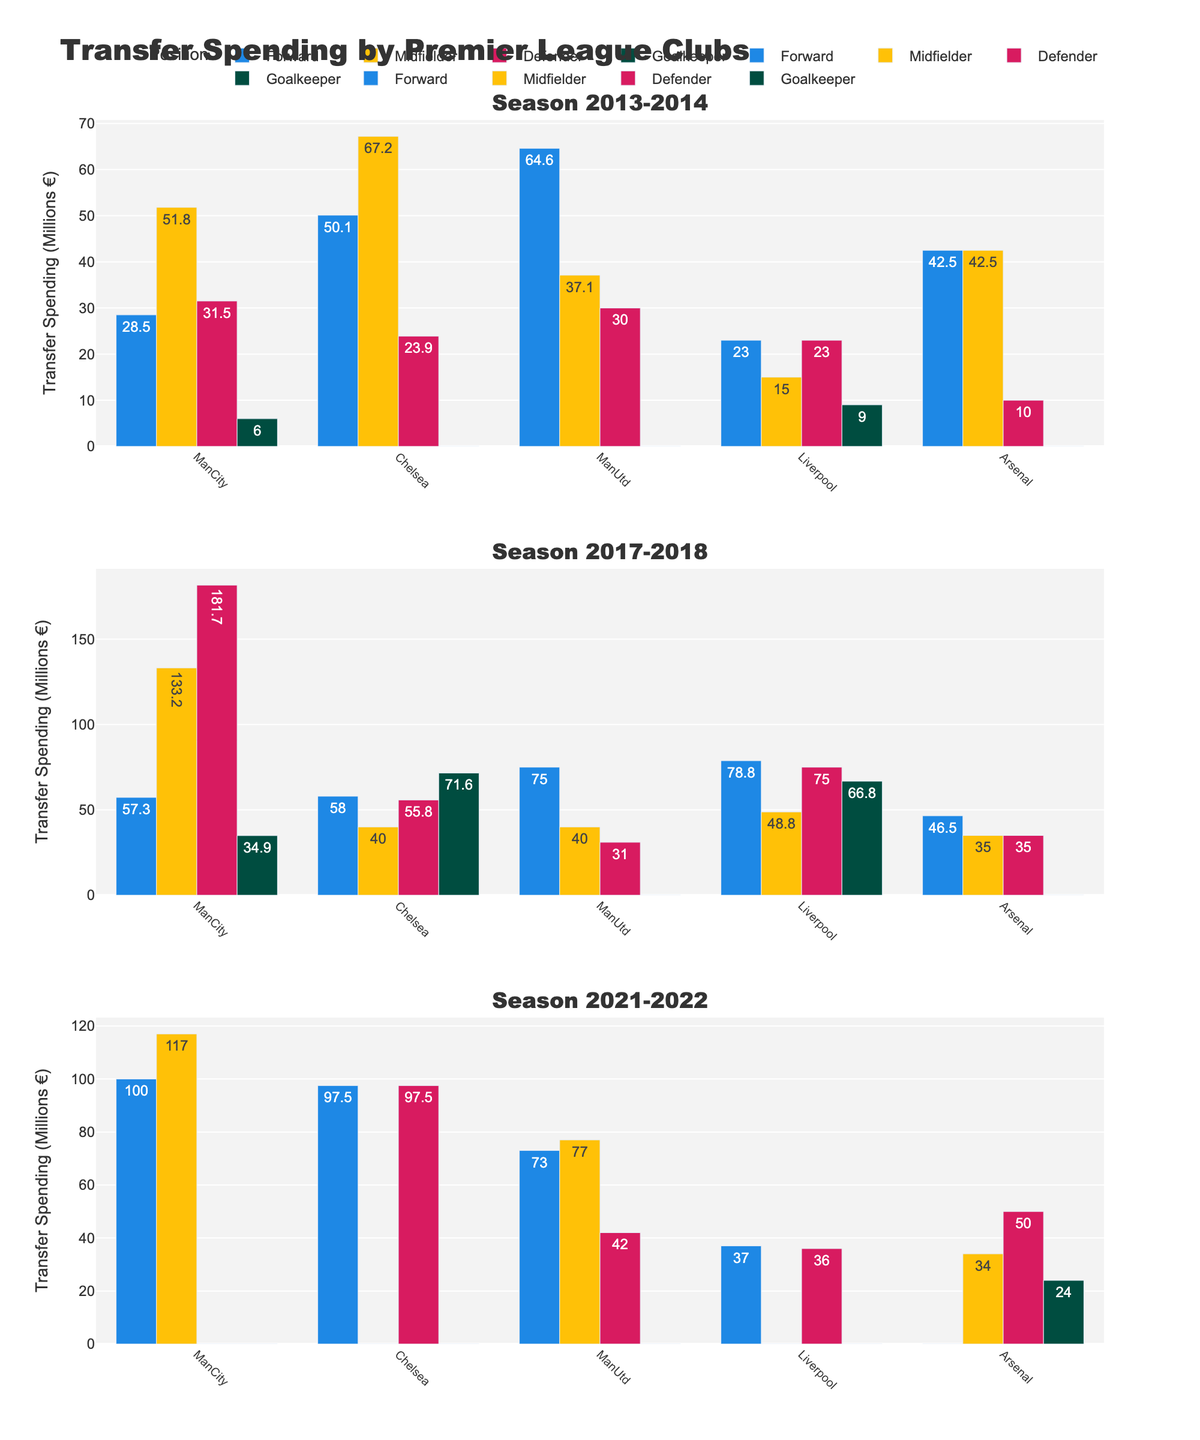What is the title of the figure? The title is displayed at the top of the figure, giving an overall description of what the figure represents, which is "Transfer Spending by Premier League Clubs".
Answer: Transfer Spending by Premier League Clubs How many seasons are displayed in the figure? Each season is represented as a separate subplot, so by counting the subplots, we can determine the number of seasons displayed. There are three subplots in the figure.
Answer: 3 Which club spent the most on defenders in the 2017-2018 season? By looking at the bar heights in the subplot for the 2017-2018 season and focusing on the 'Defender' category, we observe that Manchester City has the highest bar.
Answer: Manchester City Which position had the highest spending by Liverpool in the 2017-2018 season? In the 2017-2018 subplot, check the bar heights for Liverpool across different positions. The highest bar for Liverpool is under 'Forward'.
Answer: Forward Compare the spending on goalkeepers by Arsenal in the 2013-2014 and 2021-2022 seasons. Which season had higher spending? Locate the goalkeepers' bars for Arsenal in the 2013-2014 and 2021-2022 subplots. In 2013-2014, the spending was 0, while in 2021-2022, it was 24M. Therefore, 2021-2022 had higher spending.
Answer: 2021-2022 What is the combined total spending on forwards by Manchester United across all seasons shown? Sum the spending values for forwards by Manchester United across the three seasons: 64.6M (2013-2014) + 75.0M (2017-2018) + 73.0M (2021-2022) = 212.6M.
Answer: 212.6M Which club had an equal spending on midfielders in the 2013-2014 and 2017-2018 seasons? By comparing the heights of the midfielders' bars in the 2013-2014 and 2017-2018 subplots, Manchester United's bars for midfielders are equal in both seasons, where the spending is 40M.
Answer: Manchester United Which position did Manchester City focus on the most in the 2021-2022 season? In the 2021-2022 subplot, observe the bar heights for Manchester City across different positions. The highest spending is on 'Forward' with a spending of 100M.
Answer: Forward What was Arsenal's spending on defenders in each season, and how did it trend? Read the defender spending amounts for Arsenal from each subplot: 10M (2013-2014), 35M (2017-2018), and 50M (2021-2022). Observing the values, the spending increased each season.
Answer: Increasing trend 